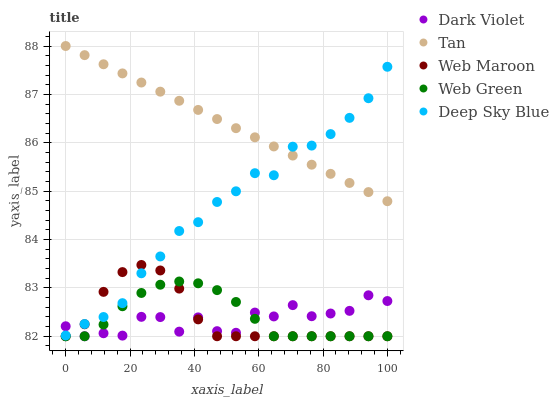Does Dark Violet have the minimum area under the curve?
Answer yes or no. Yes. Does Tan have the maximum area under the curve?
Answer yes or no. Yes. Does Web Maroon have the minimum area under the curve?
Answer yes or no. No. Does Web Maroon have the maximum area under the curve?
Answer yes or no. No. Is Tan the smoothest?
Answer yes or no. Yes. Is Dark Violet the roughest?
Answer yes or no. Yes. Is Web Maroon the smoothest?
Answer yes or no. No. Is Web Maroon the roughest?
Answer yes or no. No. Does Web Maroon have the lowest value?
Answer yes or no. Yes. Does Tan have the lowest value?
Answer yes or no. No. Does Tan have the highest value?
Answer yes or no. Yes. Does Web Maroon have the highest value?
Answer yes or no. No. Is Dark Violet less than Tan?
Answer yes or no. Yes. Is Deep Sky Blue greater than Web Green?
Answer yes or no. Yes. Does Web Maroon intersect Deep Sky Blue?
Answer yes or no. Yes. Is Web Maroon less than Deep Sky Blue?
Answer yes or no. No. Is Web Maroon greater than Deep Sky Blue?
Answer yes or no. No. Does Dark Violet intersect Tan?
Answer yes or no. No. 